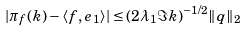<formula> <loc_0><loc_0><loc_500><loc_500>| \pi _ { f } ( k ) - \langle f , e _ { 1 } \rangle | \leq ( 2 \lambda _ { 1 } \Im k ) ^ { - 1 / 2 } \| q \| _ { 2 }</formula> 